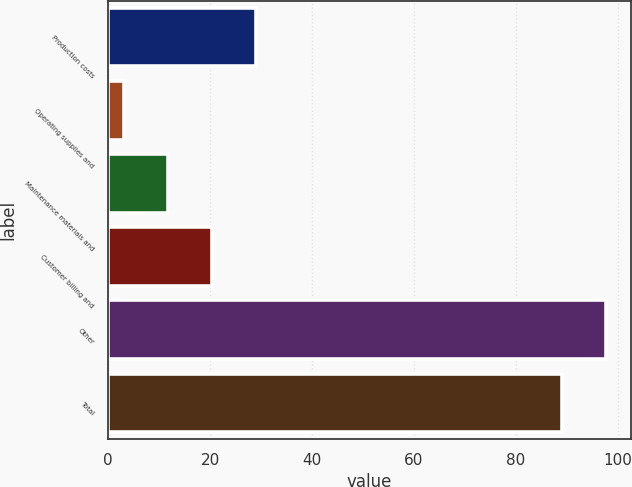<chart> <loc_0><loc_0><loc_500><loc_500><bar_chart><fcel>Production costs<fcel>Operating supplies and<fcel>Maintenance materials and<fcel>Customer billing and<fcel>Other<fcel>Total<nl><fcel>29.1<fcel>3<fcel>11.7<fcel>20.4<fcel>97.7<fcel>89<nl></chart> 